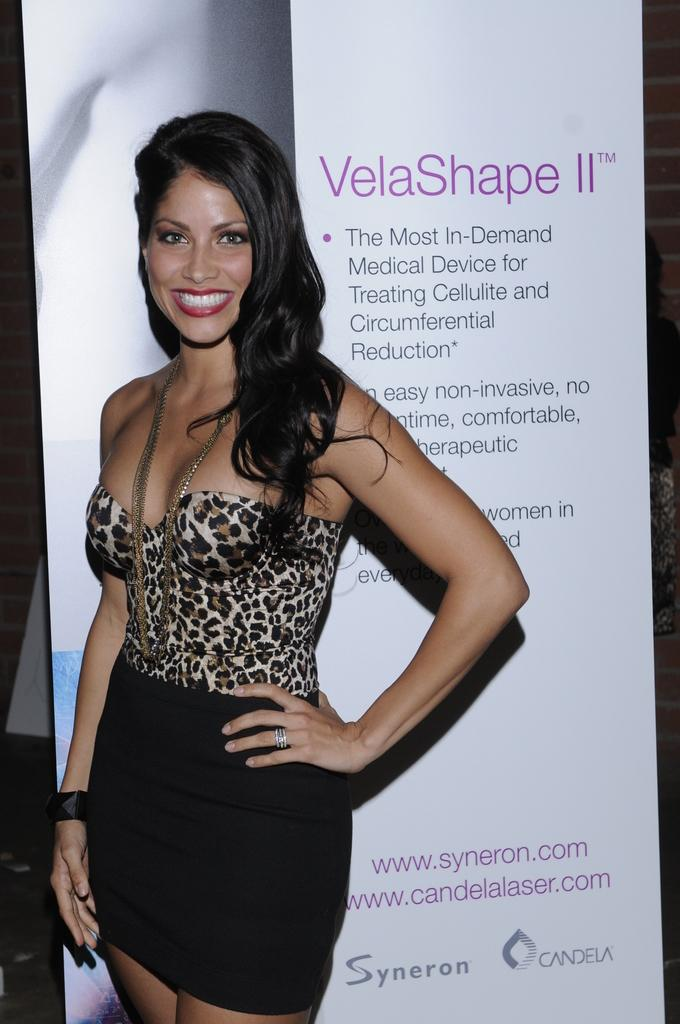What is the main subject of the image? The main subject of the image is a woman. What is the woman doing in the image? The woman is standing in the image. What is the woman's facial expression in the image? The woman is smiling in the image. What can be seen in the background of the image? There is a board in the background of the image. What type of crate is visible in the image? There is no crate present in the image. How many pins are attached to the woman's collar in the image? There is no collar or pins present on the woman in the image. 